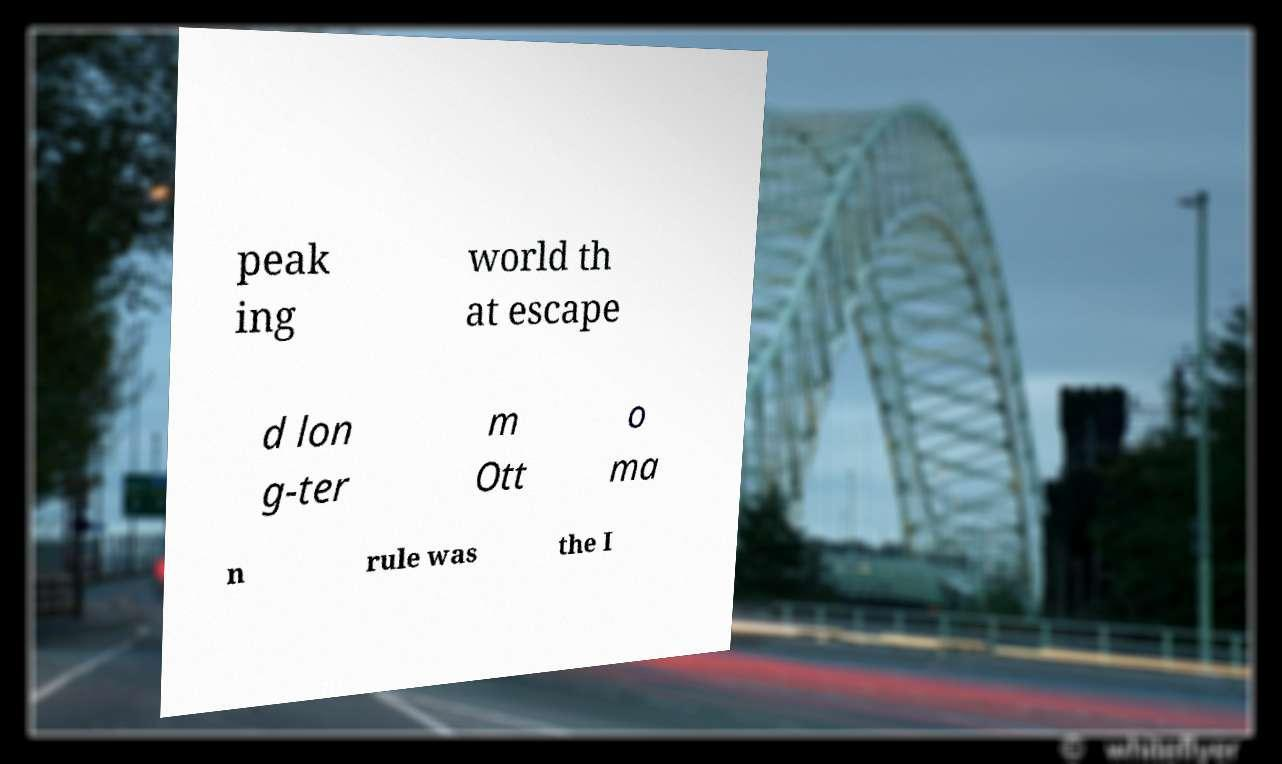Can you read and provide the text displayed in the image?This photo seems to have some interesting text. Can you extract and type it out for me? peak ing world th at escape d lon g-ter m Ott o ma n rule was the I 